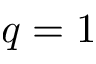<formula> <loc_0><loc_0><loc_500><loc_500>q = 1</formula> 